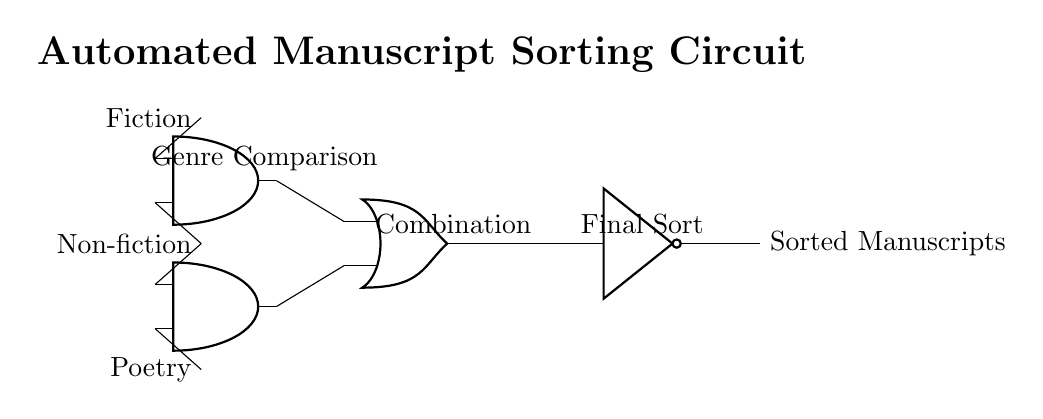What are the input signals in this circuit? The input signals are Fiction, Non-fiction, and Poetry, shown on the left side of the diagram.
Answer: Fiction, Non-fiction, Poetry What type of logic gate is used for Genre Comparison? The Genre Comparison uses AND gates, which are represented in the circuit diagram as two inputs combining to produce an output only if all inputs are true.
Answer: AND gate How many AND gates are present in this circuit? There are two AND gates in the circuit, indicated by the symbols for the AND gates in the diagram.
Answer: 2 What is the output of the OR gate? The output of the OR gate is determined by the outputs from the AND gates, which feed into it, and will be an active signal if at least one input is active.
Answer: Combination What does the NOT gate do in this circuit? The NOT gate inverts the signal it receives, transforming the input from the OR gate to produce the final sorted output, which indicates a sorted manuscript.
Answer: Final Sort What type of logic circuit is this? This circuit is a logic gate circuit specifically designed to sort manuscripts based on genre inputs, utilizing AND, OR, and NOT gates.
Answer: Logic gate circuit 